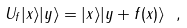Convert formula to latex. <formula><loc_0><loc_0><loc_500><loc_500>U _ { f } | x \rangle | y \rangle = | x \rangle | y + f ( x ) \rangle \ ,</formula> 